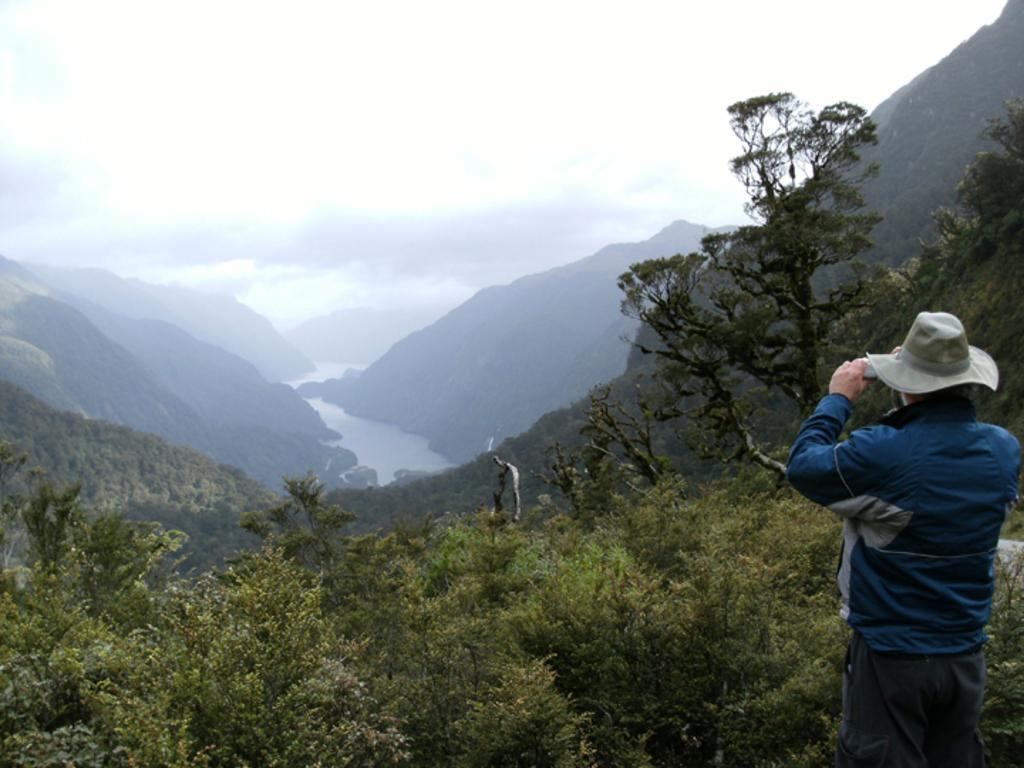Where is the man located in the image? The man is on the right side of the image. What is the man wearing? The man is wearing a jacket and trousers. What is the man holding in the image? The man is holding an object. What can be seen in the middle of the image? There are trees, hills, water, the sky, and clouds in the middle of the image. What type of crayon is the laborer using to draw approval on the trees in the image? There is no laborer, crayon, or approval present in the image. 